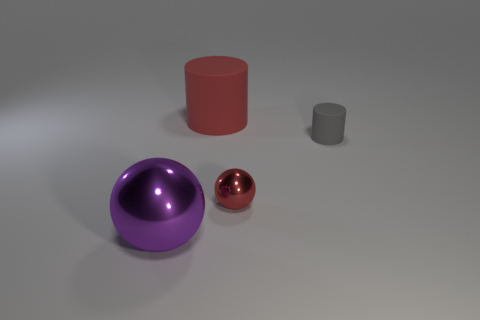Add 4 tiny red balls. How many objects exist? 8 Subtract 0 gray cubes. How many objects are left? 4 Subtract 1 cylinders. How many cylinders are left? 1 Subtract all yellow spheres. Subtract all blue cylinders. How many spheres are left? 2 Subtract all red cylinders. How many purple balls are left? 1 Subtract all gray objects. Subtract all big cyan balls. How many objects are left? 3 Add 1 purple shiny objects. How many purple shiny objects are left? 2 Add 2 gray cylinders. How many gray cylinders exist? 3 